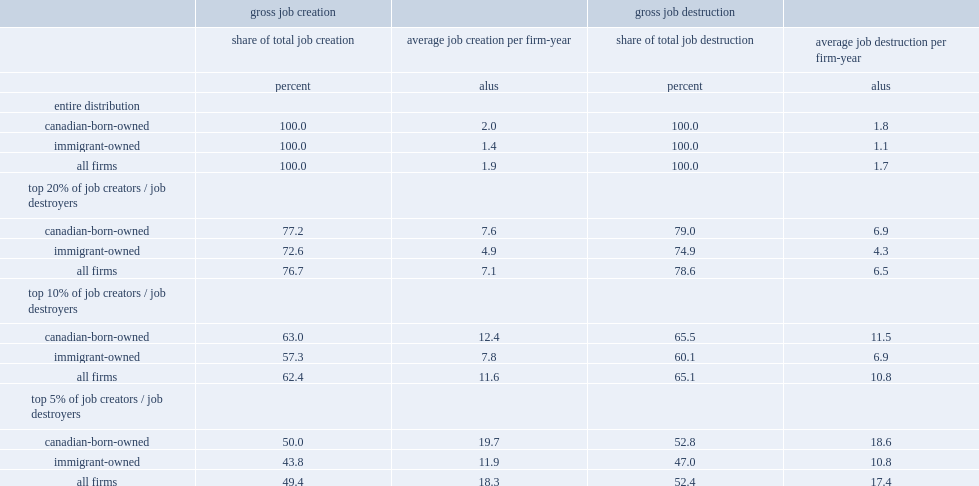How many percent of gross jobs creation did the top 5% account for? 49.4. How many jobs did the top 5% creat an annual average jobs per firm? 18.3. What was the percent of all jobs lost the top 5% of job destroyers accounted for? 52.4. 